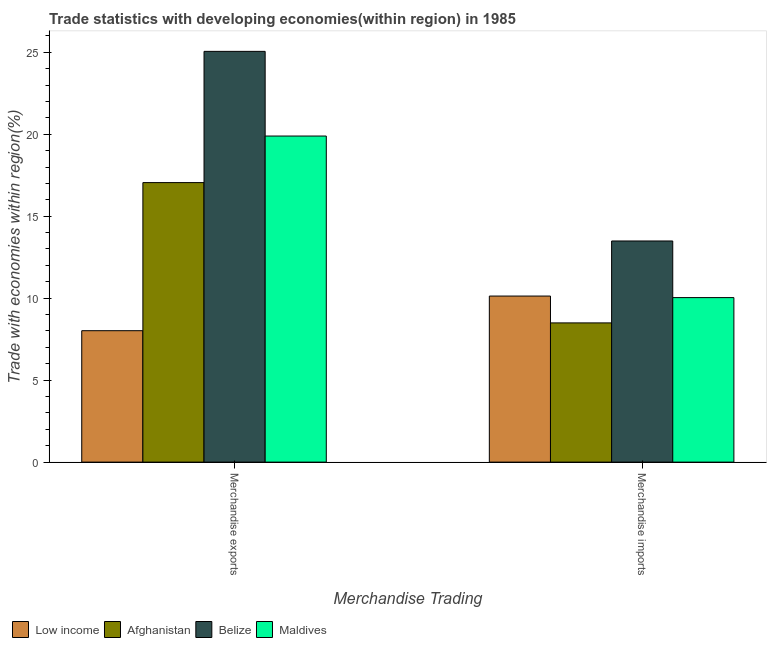How many different coloured bars are there?
Your response must be concise. 4. Are the number of bars per tick equal to the number of legend labels?
Provide a succinct answer. Yes. How many bars are there on the 2nd tick from the left?
Keep it short and to the point. 4. What is the merchandise exports in Belize?
Your response must be concise. 25.05. Across all countries, what is the maximum merchandise exports?
Keep it short and to the point. 25.05. Across all countries, what is the minimum merchandise exports?
Offer a very short reply. 8.02. In which country was the merchandise imports maximum?
Provide a short and direct response. Belize. In which country was the merchandise imports minimum?
Make the answer very short. Afghanistan. What is the total merchandise imports in the graph?
Offer a terse response. 42.15. What is the difference between the merchandise imports in Maldives and that in Belize?
Provide a short and direct response. -3.45. What is the difference between the merchandise exports in Belize and the merchandise imports in Low income?
Your answer should be compact. 14.93. What is the average merchandise imports per country?
Offer a very short reply. 10.54. What is the difference between the merchandise exports and merchandise imports in Low income?
Keep it short and to the point. -2.11. What is the ratio of the merchandise exports in Afghanistan to that in Low income?
Ensure brevity in your answer.  2.13. Is the merchandise imports in Low income less than that in Afghanistan?
Ensure brevity in your answer.  No. In how many countries, is the merchandise exports greater than the average merchandise exports taken over all countries?
Your answer should be compact. 2. What does the 2nd bar from the left in Merchandise exports represents?
Ensure brevity in your answer.  Afghanistan. How many countries are there in the graph?
Give a very brief answer. 4. What is the difference between two consecutive major ticks on the Y-axis?
Offer a terse response. 5. Where does the legend appear in the graph?
Ensure brevity in your answer.  Bottom left. What is the title of the graph?
Provide a short and direct response. Trade statistics with developing economies(within region) in 1985. Does "Palau" appear as one of the legend labels in the graph?
Your response must be concise. No. What is the label or title of the X-axis?
Provide a succinct answer. Merchandise Trading. What is the label or title of the Y-axis?
Your response must be concise. Trade with economies within region(%). What is the Trade with economies within region(%) of Low income in Merchandise exports?
Your answer should be very brief. 8.02. What is the Trade with economies within region(%) of Afghanistan in Merchandise exports?
Your answer should be very brief. 17.05. What is the Trade with economies within region(%) of Belize in Merchandise exports?
Your answer should be compact. 25.05. What is the Trade with economies within region(%) in Maldives in Merchandise exports?
Your answer should be compact. 19.89. What is the Trade with economies within region(%) of Low income in Merchandise imports?
Ensure brevity in your answer.  10.13. What is the Trade with economies within region(%) of Afghanistan in Merchandise imports?
Offer a terse response. 8.49. What is the Trade with economies within region(%) of Belize in Merchandise imports?
Your answer should be very brief. 13.49. What is the Trade with economies within region(%) of Maldives in Merchandise imports?
Your answer should be very brief. 10.04. Across all Merchandise Trading, what is the maximum Trade with economies within region(%) of Low income?
Your answer should be compact. 10.13. Across all Merchandise Trading, what is the maximum Trade with economies within region(%) of Afghanistan?
Your answer should be compact. 17.05. Across all Merchandise Trading, what is the maximum Trade with economies within region(%) in Belize?
Your answer should be very brief. 25.05. Across all Merchandise Trading, what is the maximum Trade with economies within region(%) of Maldives?
Your response must be concise. 19.89. Across all Merchandise Trading, what is the minimum Trade with economies within region(%) of Low income?
Ensure brevity in your answer.  8.02. Across all Merchandise Trading, what is the minimum Trade with economies within region(%) in Afghanistan?
Your answer should be compact. 8.49. Across all Merchandise Trading, what is the minimum Trade with economies within region(%) in Belize?
Provide a short and direct response. 13.49. Across all Merchandise Trading, what is the minimum Trade with economies within region(%) of Maldives?
Make the answer very short. 10.04. What is the total Trade with economies within region(%) in Low income in the graph?
Ensure brevity in your answer.  18.15. What is the total Trade with economies within region(%) of Afghanistan in the graph?
Make the answer very short. 25.54. What is the total Trade with economies within region(%) in Belize in the graph?
Provide a succinct answer. 38.54. What is the total Trade with economies within region(%) of Maldives in the graph?
Ensure brevity in your answer.  29.93. What is the difference between the Trade with economies within region(%) of Low income in Merchandise exports and that in Merchandise imports?
Offer a terse response. -2.11. What is the difference between the Trade with economies within region(%) of Afghanistan in Merchandise exports and that in Merchandise imports?
Offer a terse response. 8.56. What is the difference between the Trade with economies within region(%) of Belize in Merchandise exports and that in Merchandise imports?
Make the answer very short. 11.57. What is the difference between the Trade with economies within region(%) in Maldives in Merchandise exports and that in Merchandise imports?
Provide a succinct answer. 9.85. What is the difference between the Trade with economies within region(%) of Low income in Merchandise exports and the Trade with economies within region(%) of Afghanistan in Merchandise imports?
Offer a terse response. -0.48. What is the difference between the Trade with economies within region(%) in Low income in Merchandise exports and the Trade with economies within region(%) in Belize in Merchandise imports?
Ensure brevity in your answer.  -5.47. What is the difference between the Trade with economies within region(%) in Low income in Merchandise exports and the Trade with economies within region(%) in Maldives in Merchandise imports?
Your answer should be very brief. -2.02. What is the difference between the Trade with economies within region(%) of Afghanistan in Merchandise exports and the Trade with economies within region(%) of Belize in Merchandise imports?
Offer a very short reply. 3.56. What is the difference between the Trade with economies within region(%) of Afghanistan in Merchandise exports and the Trade with economies within region(%) of Maldives in Merchandise imports?
Your answer should be very brief. 7.01. What is the difference between the Trade with economies within region(%) in Belize in Merchandise exports and the Trade with economies within region(%) in Maldives in Merchandise imports?
Your response must be concise. 15.02. What is the average Trade with economies within region(%) of Low income per Merchandise Trading?
Your response must be concise. 9.07. What is the average Trade with economies within region(%) in Afghanistan per Merchandise Trading?
Make the answer very short. 12.77. What is the average Trade with economies within region(%) of Belize per Merchandise Trading?
Ensure brevity in your answer.  19.27. What is the average Trade with economies within region(%) of Maldives per Merchandise Trading?
Your answer should be very brief. 14.96. What is the difference between the Trade with economies within region(%) of Low income and Trade with economies within region(%) of Afghanistan in Merchandise exports?
Ensure brevity in your answer.  -9.03. What is the difference between the Trade with economies within region(%) in Low income and Trade with economies within region(%) in Belize in Merchandise exports?
Ensure brevity in your answer.  -17.04. What is the difference between the Trade with economies within region(%) in Low income and Trade with economies within region(%) in Maldives in Merchandise exports?
Your response must be concise. -11.87. What is the difference between the Trade with economies within region(%) of Afghanistan and Trade with economies within region(%) of Belize in Merchandise exports?
Your response must be concise. -8. What is the difference between the Trade with economies within region(%) in Afghanistan and Trade with economies within region(%) in Maldives in Merchandise exports?
Keep it short and to the point. -2.84. What is the difference between the Trade with economies within region(%) of Belize and Trade with economies within region(%) of Maldives in Merchandise exports?
Your response must be concise. 5.17. What is the difference between the Trade with economies within region(%) of Low income and Trade with economies within region(%) of Afghanistan in Merchandise imports?
Make the answer very short. 1.64. What is the difference between the Trade with economies within region(%) of Low income and Trade with economies within region(%) of Belize in Merchandise imports?
Ensure brevity in your answer.  -3.36. What is the difference between the Trade with economies within region(%) in Low income and Trade with economies within region(%) in Maldives in Merchandise imports?
Keep it short and to the point. 0.09. What is the difference between the Trade with economies within region(%) of Afghanistan and Trade with economies within region(%) of Belize in Merchandise imports?
Keep it short and to the point. -5. What is the difference between the Trade with economies within region(%) in Afghanistan and Trade with economies within region(%) in Maldives in Merchandise imports?
Make the answer very short. -1.54. What is the difference between the Trade with economies within region(%) of Belize and Trade with economies within region(%) of Maldives in Merchandise imports?
Keep it short and to the point. 3.45. What is the ratio of the Trade with economies within region(%) of Low income in Merchandise exports to that in Merchandise imports?
Give a very brief answer. 0.79. What is the ratio of the Trade with economies within region(%) of Afghanistan in Merchandise exports to that in Merchandise imports?
Provide a succinct answer. 2.01. What is the ratio of the Trade with economies within region(%) in Belize in Merchandise exports to that in Merchandise imports?
Make the answer very short. 1.86. What is the ratio of the Trade with economies within region(%) of Maldives in Merchandise exports to that in Merchandise imports?
Give a very brief answer. 1.98. What is the difference between the highest and the second highest Trade with economies within region(%) of Low income?
Ensure brevity in your answer.  2.11. What is the difference between the highest and the second highest Trade with economies within region(%) in Afghanistan?
Provide a succinct answer. 8.56. What is the difference between the highest and the second highest Trade with economies within region(%) in Belize?
Offer a very short reply. 11.57. What is the difference between the highest and the second highest Trade with economies within region(%) of Maldives?
Offer a terse response. 9.85. What is the difference between the highest and the lowest Trade with economies within region(%) in Low income?
Provide a succinct answer. 2.11. What is the difference between the highest and the lowest Trade with economies within region(%) of Afghanistan?
Offer a very short reply. 8.56. What is the difference between the highest and the lowest Trade with economies within region(%) of Belize?
Keep it short and to the point. 11.57. What is the difference between the highest and the lowest Trade with economies within region(%) in Maldives?
Your answer should be very brief. 9.85. 